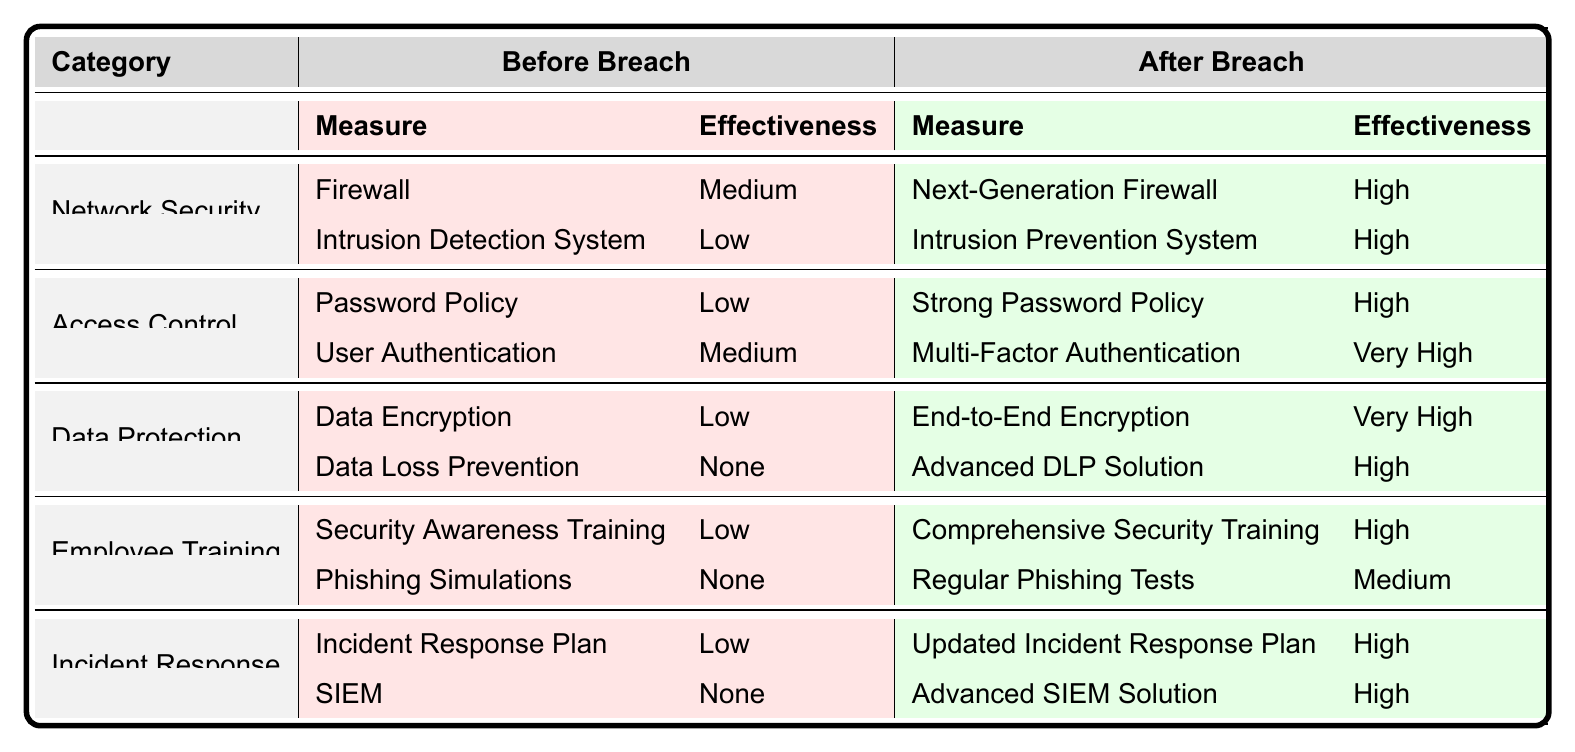What security measure in the Data Protection category had the lowest effectiveness before the breach? In the Data Protection category, the measures listed before the breach include Data Encryption with Low effectiveness and Data Loss Prevention with None effectiveness. Since None is lower than Low, Data Loss Prevention had the lowest effectiveness before the breach.
Answer: Data Loss Prevention What improvement in effectiveness was seen for the Password Policy after the breach? The effectiveness of the Password Policy before the breach was Low and after the breach, it became High. To calculate the improvement, we see it changed from Low to High, resulting in an increase of effectiveness.
Answer: Improvement from Low to High Is Multi-Factor Authentication used in the company's Access Control measures before the breach? According to the table, Multi-Factor Authentication is listed only in the Access Control measures after the breach, therefore it was not used before the breach.
Answer: No Which category shows the highest effectiveness rating after the breach and what are the measures in that category? After the breach, the Data Protection category shows the highest effectiveness ratings: End-to-End Encryption rated Very High and Advanced DLP Solution rated High. Thus, the measures in this category are End-to-End Encryption and Advanced DLP Solution.
Answer: Data Protection: End-to-End Encryption (Very High), Advanced DLP Solution (High) How many measures in the Employee Training category changed from Low effectiveness to High effectiveness after the breach? In the Employee Training category, the measures before the breach were Security Awareness Training with Low effectiveness and Phishing Simulations, also with None effectiveness. After the breach, Comprehensive Security Training rated High and Regular Phishing Tests rated Medium. Thus, only one measure, Comprehensive Security Training, changed to High effectiveness.
Answer: One measure Was there an improvement in the effectiveness of the Incident Response Plan after the breach, and if so, by how much? The Incident Response Plan's effectiveness before the breach was Low, and after the breach, it rated High. The improvement was from Low to High, indicating a significant enhancement in effectiveness.
Answer: Yes, improvement from Low to High Which specific measure was implemented after the breach to enhance Network Security and what is its effectiveness? After the breach, the measure implemented in Network Security was the Next-Generation Firewall, which is rated as High for effectiveness.
Answer: Next-Generation Firewall, effectiveness High How did the effectiveness of Data Loss Prevention change post-breach? Data Loss Prevention had None effectiveness before the breach and improved to High effectiveness after the breach with the implementation of an Advanced DLP Solution. Therefore, it changed from None to High.
Answer: None to High Which category had measures with both High and Very High effectiveness ratings after the breach? After the breach, the Data Protection category had one measure rated Very High (End-to-End Encryption) and another measure rated High (Advanced DLP Solution). This makes it the only category with both ratings.
Answer: Data Protection category Which category saw the least improvement in overall effectiveness ratings after the breach? The Employee Training category had measures that were rated Low and None before the breach, and after the breach, the ratings improved only to Medium or High. Compared to other categories that largely improved to High and Very High, this represents the least improvement.
Answer: Employee Training category 